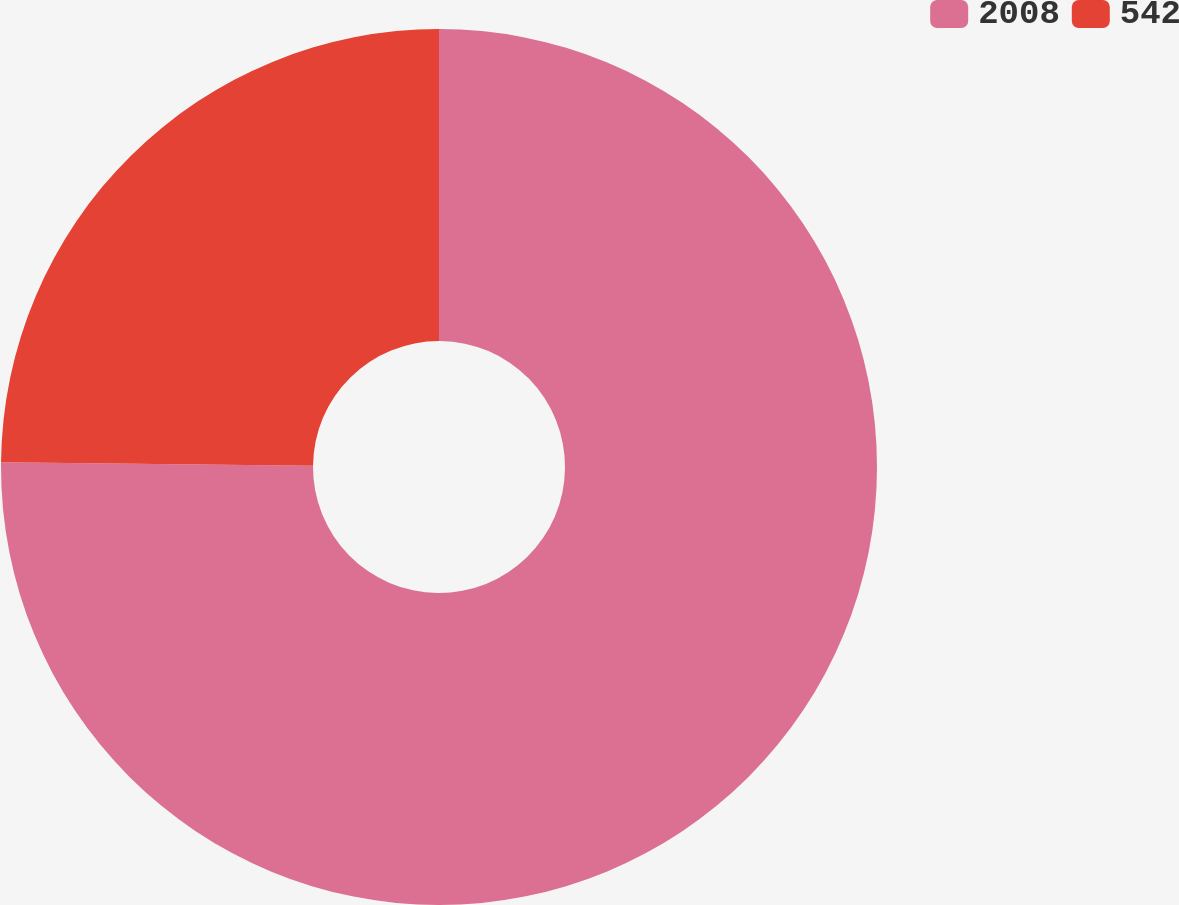Convert chart to OTSL. <chart><loc_0><loc_0><loc_500><loc_500><pie_chart><fcel>2008<fcel>542<nl><fcel>75.17%<fcel>24.83%<nl></chart> 